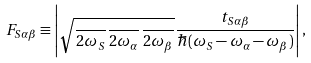Convert formula to latex. <formula><loc_0><loc_0><loc_500><loc_500>F _ { S \alpha \beta } \equiv \left | \sqrt { \frac { } { 2 { \omega } _ { S } } \frac { } { 2 { \omega } _ { \alpha } } \frac { } { 2 { \omega } _ { \beta } } } \frac { t _ { S \alpha \beta } } { \hbar { ( } { \omega } _ { S } - \omega _ { \alpha } - \omega _ { \beta } ) } \right | ,</formula> 